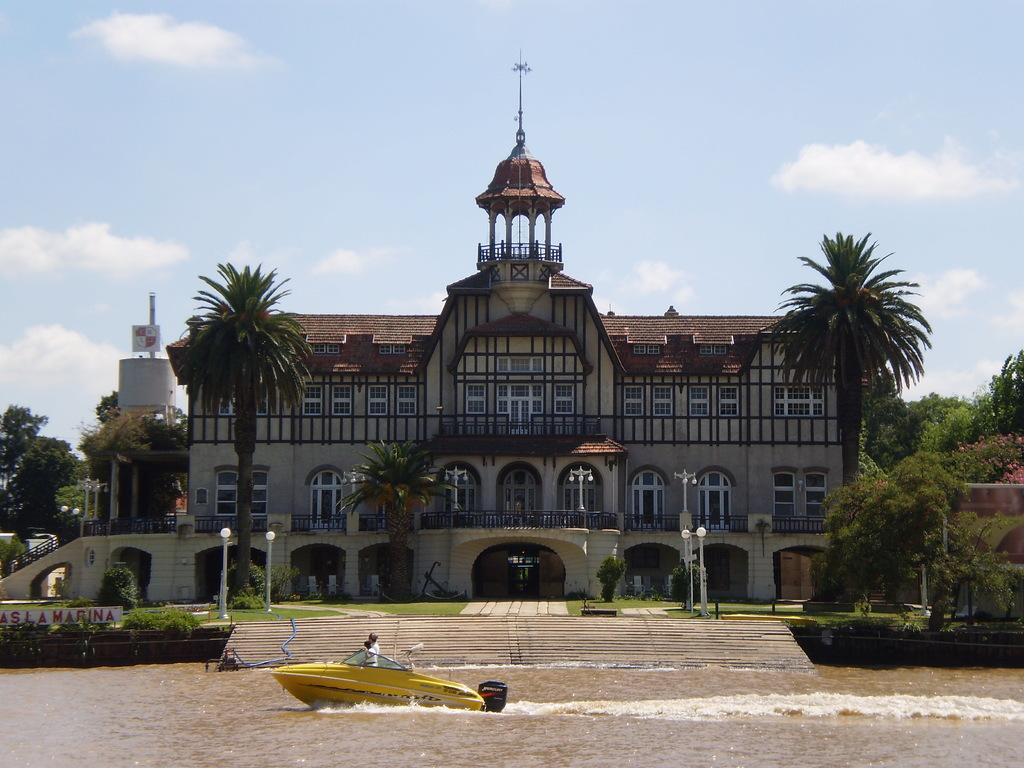Where was the image taken? The image was taken outside. What is the main subject in the middle of the image? There is a building and trees in the middle of the image. What can be seen at the bottom of the image? There is water at the bottom of the image, and a boat is in the water. What is visible at the top of the image? There is sky at the top of the image. How many deer can be seen in the image? There are no deer present in the image. What sound does the whistle make in the image? There is no whistle present in the image. 